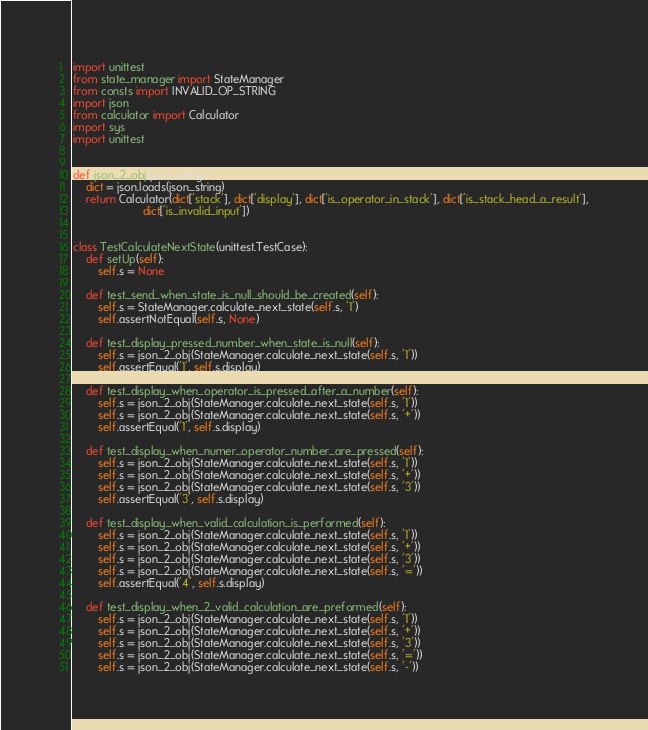Convert code to text. <code><loc_0><loc_0><loc_500><loc_500><_Python_>import unittest
from state_manager import StateManager
from consts import INVALID_OP_STRING
import json
from calculator import Calculator
import sys
import unittest


def json_2_obj(json_string):
    dict = json.loads(json_string)
    return Calculator(dict['stack'], dict['display'], dict['is_operator_in_stack'], dict['is_stack_head_a_result'],
                      dict['is_invalid_input'])


class TestCalculateNextState(unittest.TestCase):
    def setUp(self):
        self.s = None

    def test_send_when_state_is_null_should_be_created(self):
        self.s = StateManager.calculate_next_state(self.s, '1')
        self.assertNotEqual(self.s, None)

    def test_display_pressed_number_when_state_is_null(self):
        self.s = json_2_obj(StateManager.calculate_next_state(self.s, '1'))
        self.assertEqual('1', self.s.display)

    def test_display_when_operator_is_pressed_after_a_number(self):
        self.s = json_2_obj(StateManager.calculate_next_state(self.s, '1'))
        self.s = json_2_obj(StateManager.calculate_next_state(self.s, '+'))
        self.assertEqual('1', self.s.display)

    def test_display_when_numer_operator_number_are_pressed(self):
        self.s = json_2_obj(StateManager.calculate_next_state(self.s, '1'))
        self.s = json_2_obj(StateManager.calculate_next_state(self.s, '+'))
        self.s = json_2_obj(StateManager.calculate_next_state(self.s, '3'))
        self.assertEqual('3', self.s.display)

    def test_display_when_valid_calculation_is_performed(self):
        self.s = json_2_obj(StateManager.calculate_next_state(self.s, '1'))
        self.s = json_2_obj(StateManager.calculate_next_state(self.s, '+'))
        self.s = json_2_obj(StateManager.calculate_next_state(self.s, '3'))
        self.s = json_2_obj(StateManager.calculate_next_state(self.s, '='))
        self.assertEqual('4', self.s.display)

    def test_display_when_2_valid_calculation_are_preformed(self):
        self.s = json_2_obj(StateManager.calculate_next_state(self.s, '1'))
        self.s = json_2_obj(StateManager.calculate_next_state(self.s, '+'))
        self.s = json_2_obj(StateManager.calculate_next_state(self.s, '3'))
        self.s = json_2_obj(StateManager.calculate_next_state(self.s, '='))
        self.s = json_2_obj(StateManager.calculate_next_state(self.s, '-'))</code> 